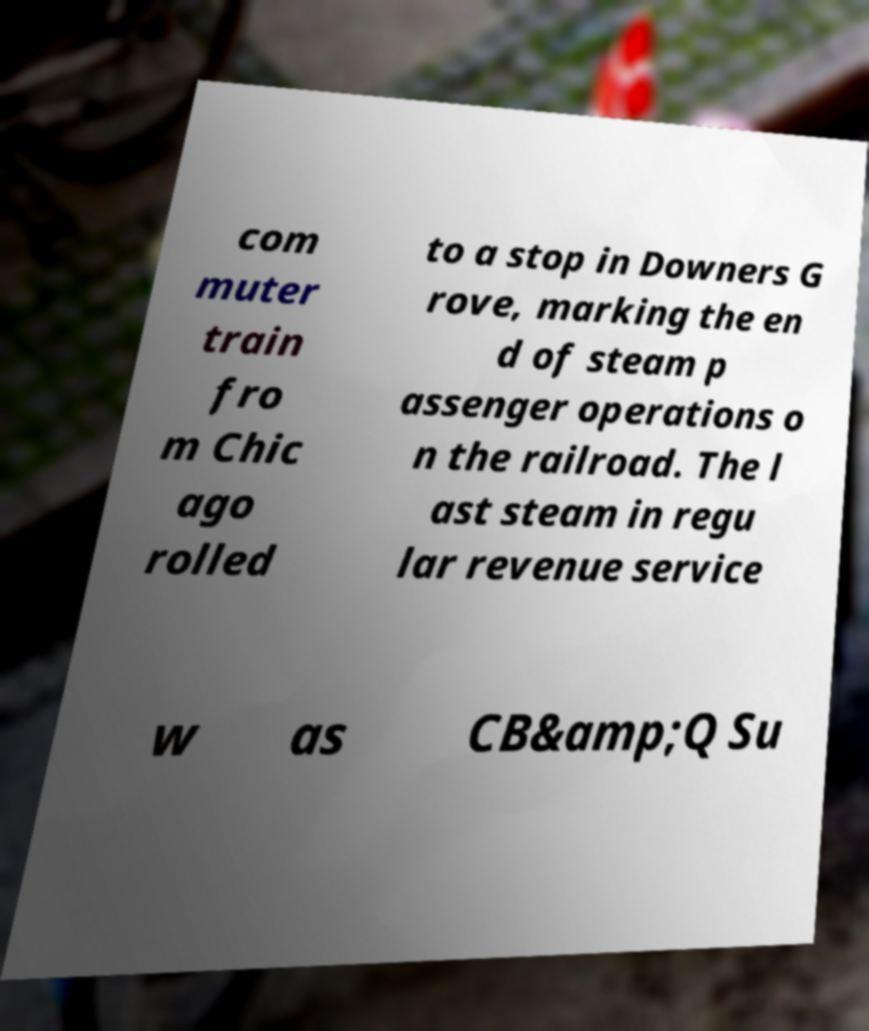What messages or text are displayed in this image? I need them in a readable, typed format. com muter train fro m Chic ago rolled to a stop in Downers G rove, marking the en d of steam p assenger operations o n the railroad. The l ast steam in regu lar revenue service w as CB&amp;Q Su 